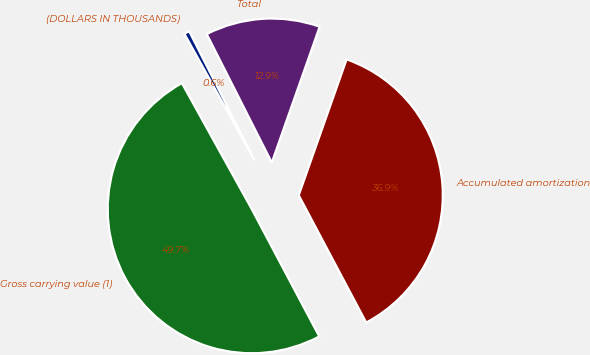Convert chart to OTSL. <chart><loc_0><loc_0><loc_500><loc_500><pie_chart><fcel>(DOLLARS IN THOUSANDS)<fcel>Gross carrying value (1)<fcel>Accumulated amortization<fcel>Total<nl><fcel>0.6%<fcel>49.7%<fcel>36.85%<fcel>12.85%<nl></chart> 